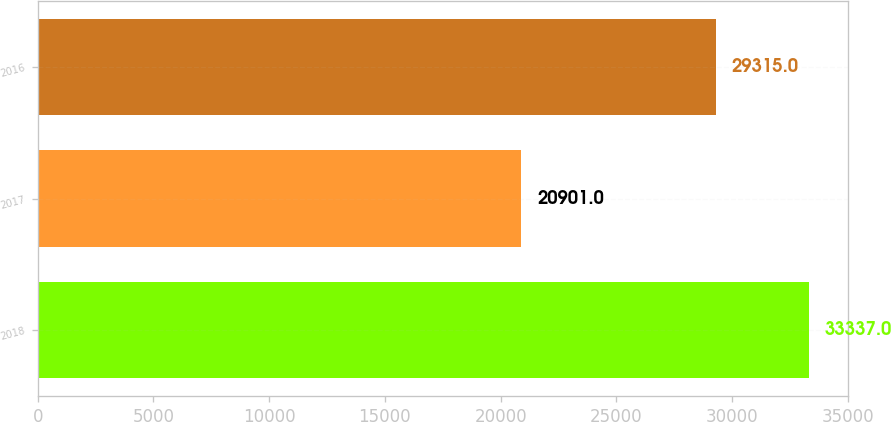<chart> <loc_0><loc_0><loc_500><loc_500><bar_chart><fcel>2018<fcel>2017<fcel>2016<nl><fcel>33337<fcel>20901<fcel>29315<nl></chart> 